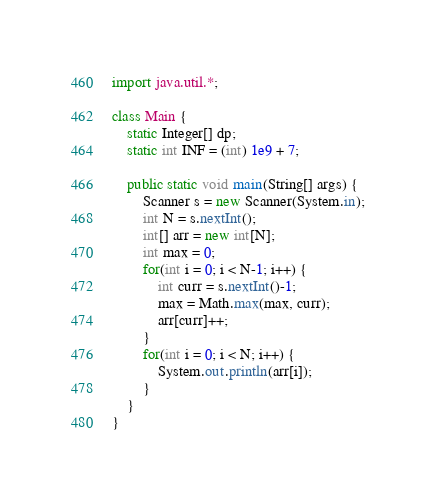<code> <loc_0><loc_0><loc_500><loc_500><_Java_>import java.util.*;

class Main {
    static Integer[] dp;
    static int INF = (int) 1e9 + 7;

    public static void main(String[] args) {
        Scanner s = new Scanner(System.in);
        int N = s.nextInt();
        int[] arr = new int[N];
        int max = 0;
        for(int i = 0; i < N-1; i++) {
            int curr = s.nextInt()-1;
            max = Math.max(max, curr);
            arr[curr]++;
        }
        for(int i = 0; i < N; i++) {
            System.out.println(arr[i]);
        }
    }
}</code> 